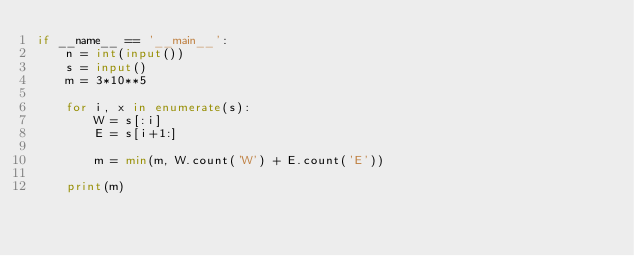Convert code to text. <code><loc_0><loc_0><loc_500><loc_500><_Python_>if __name__ == '__main__':
    n = int(input())
    s = input()
    m = 3*10**5

    for i, x in enumerate(s):
        W = s[:i]
        E = s[i+1:]

        m = min(m, W.count('W') + E.count('E'))

    print(m)
</code> 